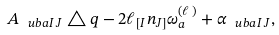Convert formula to latex. <formula><loc_0><loc_0><loc_500><loc_500>A _ { \ u b a I \, J } \triangle q - 2 \ell _ { [ I } n _ { J ] } \omega ^ { ( \ell \, ) } _ { a } + \alpha _ { \ u b a I \, J } ,</formula> 